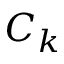Convert formula to latex. <formula><loc_0><loc_0><loc_500><loc_500>C _ { k }</formula> 